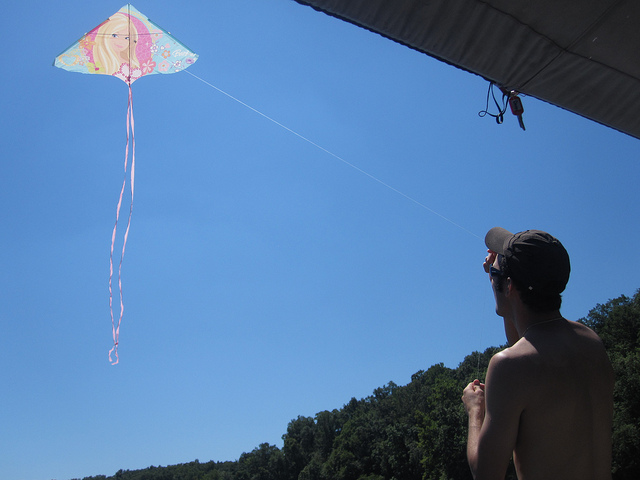What is the weather like in the image? The weather appears to be perfect for outdoor activities, clear with a blue sky and abundant sunshine, hinting at a gentle breeze that is ideal for kite flying. 